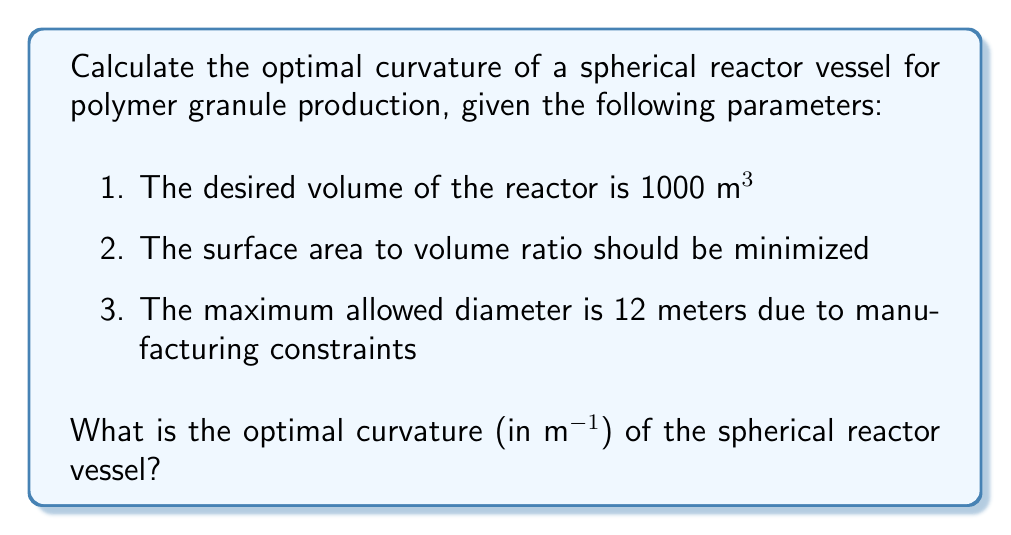Provide a solution to this math problem. To solve this problem, we'll follow these steps:

1. Recall the formulas for volume and surface area of a sphere:
   Volume: $V = \frac{4}{3}\pi r^3$
   Surface Area: $A = 4\pi r^2$

2. Given the volume constraint, calculate the radius:
   $1000 = \frac{4}{3}\pi r^3$
   $r^3 = \frac{1000 \cdot 3}{4\pi} \approx 238.73$
   $r \approx 6.21$ m

3. Check if this radius satisfies the maximum diameter constraint:
   Diameter $= 2r \approx 12.42$ m
   This exceeds the 12 m constraint, so we must use the maximum allowed radius of 6 m.

4. The curvature of a sphere is defined as the reciprocal of its radius:
   $\kappa = \frac{1}{r}$

5. Calculate the optimal curvature:
   $\kappa = \frac{1}{6} \approx 0.1667$ m⁻¹

Note: Although this curvature doesn't provide the desired volume of 1000 m³, it's the optimal solution given the manufacturing constraints.
Answer: $\frac{1}{6}$ m⁻¹ or approximately 0.1667 m⁻¹ 